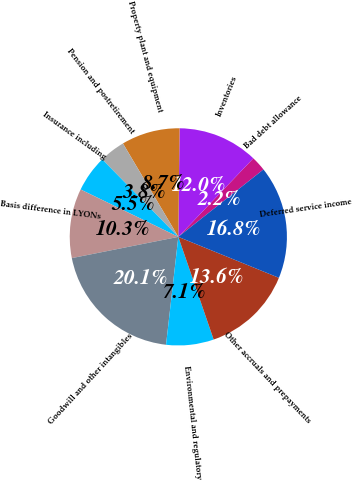<chart> <loc_0><loc_0><loc_500><loc_500><pie_chart><fcel>Bad debt allowance<fcel>Inventories<fcel>Property plant and equipment<fcel>Pension and postretirement<fcel>Insurance including<fcel>Basis difference in LYONs<fcel>Goodwill and other intangibles<fcel>Environmental and regulatory<fcel>Other accruals and prepayments<fcel>Deferred service income<nl><fcel>2.21%<fcel>11.95%<fcel>8.7%<fcel>3.84%<fcel>5.46%<fcel>10.32%<fcel>20.06%<fcel>7.08%<fcel>13.57%<fcel>16.81%<nl></chart> 